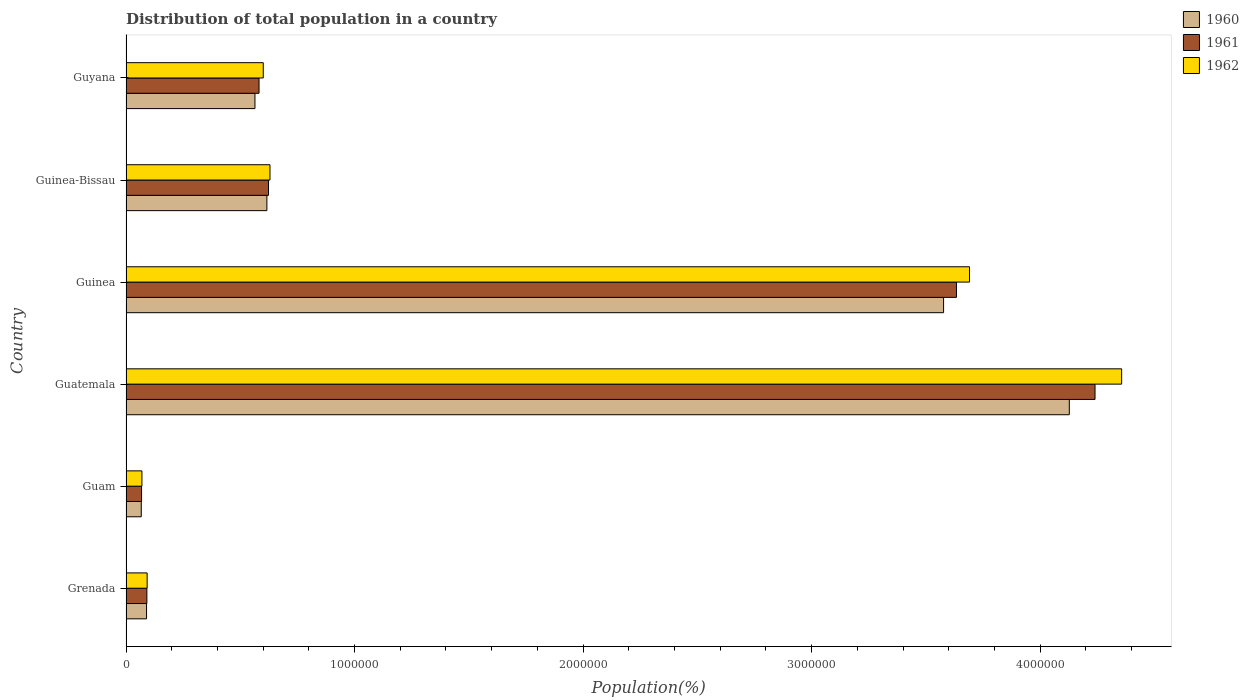How many groups of bars are there?
Offer a terse response. 6. How many bars are there on the 6th tick from the bottom?
Your response must be concise. 3. What is the label of the 5th group of bars from the top?
Provide a short and direct response. Guam. In how many cases, is the number of bars for a given country not equal to the number of legend labels?
Give a very brief answer. 0. What is the population of in 1962 in Guyana?
Keep it short and to the point. 6.01e+05. Across all countries, what is the maximum population of in 1961?
Provide a succinct answer. 4.24e+06. Across all countries, what is the minimum population of in 1962?
Keep it short and to the point. 6.96e+04. In which country was the population of in 1961 maximum?
Your answer should be very brief. Guatemala. In which country was the population of in 1961 minimum?
Your answer should be very brief. Guam. What is the total population of in 1962 in the graph?
Provide a short and direct response. 9.44e+06. What is the difference between the population of in 1961 in Grenada and that in Guinea?
Ensure brevity in your answer.  -3.54e+06. What is the difference between the population of in 1962 in Guyana and the population of in 1960 in Guinea?
Provide a succinct answer. -2.98e+06. What is the average population of in 1961 per country?
Your answer should be very brief. 1.54e+06. What is the difference between the population of in 1960 and population of in 1962 in Guinea?
Your answer should be very brief. -1.14e+05. What is the ratio of the population of in 1962 in Guatemala to that in Guinea?
Offer a terse response. 1.18. Is the difference between the population of in 1960 in Guam and Guinea greater than the difference between the population of in 1962 in Guam and Guinea?
Your answer should be very brief. Yes. What is the difference between the highest and the second highest population of in 1960?
Offer a terse response. 5.50e+05. What is the difference between the highest and the lowest population of in 1961?
Provide a short and direct response. 4.17e+06. In how many countries, is the population of in 1960 greater than the average population of in 1960 taken over all countries?
Offer a very short reply. 2. Are all the bars in the graph horizontal?
Your response must be concise. Yes. What is the difference between two consecutive major ticks on the X-axis?
Your answer should be very brief. 1.00e+06. Are the values on the major ticks of X-axis written in scientific E-notation?
Offer a terse response. No. Does the graph contain any zero values?
Offer a terse response. No. Does the graph contain grids?
Your response must be concise. No. How are the legend labels stacked?
Keep it short and to the point. Vertical. What is the title of the graph?
Your answer should be very brief. Distribution of total population in a country. What is the label or title of the X-axis?
Offer a very short reply. Population(%). What is the Population(%) of 1960 in Grenada?
Your answer should be compact. 8.99e+04. What is the Population(%) of 1961 in Grenada?
Your answer should be very brief. 9.13e+04. What is the Population(%) in 1962 in Grenada?
Your answer should be compact. 9.24e+04. What is the Population(%) in 1960 in Guam?
Your answer should be very brief. 6.67e+04. What is the Population(%) of 1961 in Guam?
Offer a very short reply. 6.81e+04. What is the Population(%) of 1962 in Guam?
Keep it short and to the point. 6.96e+04. What is the Population(%) of 1960 in Guatemala?
Offer a very short reply. 4.13e+06. What is the Population(%) in 1961 in Guatemala?
Give a very brief answer. 4.24e+06. What is the Population(%) of 1962 in Guatemala?
Make the answer very short. 4.36e+06. What is the Population(%) in 1960 in Guinea?
Your answer should be compact. 3.58e+06. What is the Population(%) in 1961 in Guinea?
Provide a short and direct response. 3.63e+06. What is the Population(%) in 1962 in Guinea?
Your response must be concise. 3.69e+06. What is the Population(%) in 1960 in Guinea-Bissau?
Your response must be concise. 6.16e+05. What is the Population(%) in 1961 in Guinea-Bissau?
Your answer should be compact. 6.23e+05. What is the Population(%) of 1962 in Guinea-Bissau?
Your answer should be very brief. 6.30e+05. What is the Population(%) in 1960 in Guyana?
Your answer should be compact. 5.64e+05. What is the Population(%) in 1961 in Guyana?
Offer a very short reply. 5.82e+05. What is the Population(%) of 1962 in Guyana?
Your response must be concise. 6.01e+05. Across all countries, what is the maximum Population(%) of 1960?
Your response must be concise. 4.13e+06. Across all countries, what is the maximum Population(%) in 1961?
Make the answer very short. 4.24e+06. Across all countries, what is the maximum Population(%) of 1962?
Keep it short and to the point. 4.36e+06. Across all countries, what is the minimum Population(%) of 1960?
Offer a terse response. 6.67e+04. Across all countries, what is the minimum Population(%) of 1961?
Keep it short and to the point. 6.81e+04. Across all countries, what is the minimum Population(%) of 1962?
Ensure brevity in your answer.  6.96e+04. What is the total Population(%) of 1960 in the graph?
Your answer should be compact. 9.04e+06. What is the total Population(%) of 1961 in the graph?
Ensure brevity in your answer.  9.24e+06. What is the total Population(%) in 1962 in the graph?
Offer a very short reply. 9.44e+06. What is the difference between the Population(%) in 1960 in Grenada and that in Guam?
Your response must be concise. 2.31e+04. What is the difference between the Population(%) of 1961 in Grenada and that in Guam?
Make the answer very short. 2.32e+04. What is the difference between the Population(%) of 1962 in Grenada and that in Guam?
Offer a very short reply. 2.28e+04. What is the difference between the Population(%) in 1960 in Grenada and that in Guatemala?
Ensure brevity in your answer.  -4.04e+06. What is the difference between the Population(%) of 1961 in Grenada and that in Guatemala?
Your answer should be compact. -4.15e+06. What is the difference between the Population(%) in 1962 in Grenada and that in Guatemala?
Give a very brief answer. -4.26e+06. What is the difference between the Population(%) in 1960 in Grenada and that in Guinea?
Offer a very short reply. -3.49e+06. What is the difference between the Population(%) in 1961 in Grenada and that in Guinea?
Give a very brief answer. -3.54e+06. What is the difference between the Population(%) of 1962 in Grenada and that in Guinea?
Keep it short and to the point. -3.60e+06. What is the difference between the Population(%) of 1960 in Grenada and that in Guinea-Bissau?
Make the answer very short. -5.27e+05. What is the difference between the Population(%) in 1961 in Grenada and that in Guinea-Bissau?
Ensure brevity in your answer.  -5.32e+05. What is the difference between the Population(%) in 1962 in Grenada and that in Guinea-Bissau?
Offer a terse response. -5.38e+05. What is the difference between the Population(%) of 1960 in Grenada and that in Guyana?
Offer a terse response. -4.74e+05. What is the difference between the Population(%) in 1961 in Grenada and that in Guyana?
Your answer should be compact. -4.91e+05. What is the difference between the Population(%) of 1962 in Grenada and that in Guyana?
Give a very brief answer. -5.08e+05. What is the difference between the Population(%) in 1960 in Guam and that in Guatemala?
Provide a short and direct response. -4.06e+06. What is the difference between the Population(%) in 1961 in Guam and that in Guatemala?
Offer a very short reply. -4.17e+06. What is the difference between the Population(%) of 1962 in Guam and that in Guatemala?
Provide a short and direct response. -4.29e+06. What is the difference between the Population(%) in 1960 in Guam and that in Guinea?
Your answer should be very brief. -3.51e+06. What is the difference between the Population(%) of 1961 in Guam and that in Guinea?
Your answer should be very brief. -3.57e+06. What is the difference between the Population(%) of 1962 in Guam and that in Guinea?
Offer a terse response. -3.62e+06. What is the difference between the Population(%) of 1960 in Guam and that in Guinea-Bissau?
Your answer should be compact. -5.50e+05. What is the difference between the Population(%) of 1961 in Guam and that in Guinea-Bissau?
Give a very brief answer. -5.55e+05. What is the difference between the Population(%) of 1962 in Guam and that in Guinea-Bissau?
Offer a very short reply. -5.60e+05. What is the difference between the Population(%) of 1960 in Guam and that in Guyana?
Provide a short and direct response. -4.97e+05. What is the difference between the Population(%) of 1961 in Guam and that in Guyana?
Your response must be concise. -5.14e+05. What is the difference between the Population(%) in 1962 in Guam and that in Guyana?
Make the answer very short. -5.31e+05. What is the difference between the Population(%) in 1960 in Guatemala and that in Guinea?
Provide a succinct answer. 5.50e+05. What is the difference between the Population(%) in 1961 in Guatemala and that in Guinea?
Your answer should be compact. 6.06e+05. What is the difference between the Population(%) of 1962 in Guatemala and that in Guinea?
Make the answer very short. 6.66e+05. What is the difference between the Population(%) of 1960 in Guatemala and that in Guinea-Bissau?
Your answer should be very brief. 3.51e+06. What is the difference between the Population(%) in 1961 in Guatemala and that in Guinea-Bissau?
Give a very brief answer. 3.62e+06. What is the difference between the Population(%) of 1962 in Guatemala and that in Guinea-Bissau?
Your answer should be very brief. 3.73e+06. What is the difference between the Population(%) in 1960 in Guatemala and that in Guyana?
Provide a short and direct response. 3.56e+06. What is the difference between the Population(%) in 1961 in Guatemala and that in Guyana?
Make the answer very short. 3.66e+06. What is the difference between the Population(%) in 1962 in Guatemala and that in Guyana?
Keep it short and to the point. 3.76e+06. What is the difference between the Population(%) in 1960 in Guinea and that in Guinea-Bissau?
Your response must be concise. 2.96e+06. What is the difference between the Population(%) in 1961 in Guinea and that in Guinea-Bissau?
Your answer should be very brief. 3.01e+06. What is the difference between the Population(%) of 1962 in Guinea and that in Guinea-Bissau?
Offer a terse response. 3.06e+06. What is the difference between the Population(%) in 1960 in Guinea and that in Guyana?
Ensure brevity in your answer.  3.01e+06. What is the difference between the Population(%) of 1961 in Guinea and that in Guyana?
Provide a succinct answer. 3.05e+06. What is the difference between the Population(%) of 1962 in Guinea and that in Guyana?
Provide a short and direct response. 3.09e+06. What is the difference between the Population(%) in 1960 in Guinea-Bissau and that in Guyana?
Ensure brevity in your answer.  5.22e+04. What is the difference between the Population(%) in 1961 in Guinea-Bissau and that in Guyana?
Your answer should be compact. 4.14e+04. What is the difference between the Population(%) of 1962 in Guinea-Bissau and that in Guyana?
Give a very brief answer. 2.94e+04. What is the difference between the Population(%) of 1960 in Grenada and the Population(%) of 1961 in Guam?
Keep it short and to the point. 2.18e+04. What is the difference between the Population(%) of 1960 in Grenada and the Population(%) of 1962 in Guam?
Ensure brevity in your answer.  2.03e+04. What is the difference between the Population(%) of 1961 in Grenada and the Population(%) of 1962 in Guam?
Offer a very short reply. 2.17e+04. What is the difference between the Population(%) in 1960 in Grenada and the Population(%) in 1961 in Guatemala?
Ensure brevity in your answer.  -4.15e+06. What is the difference between the Population(%) of 1960 in Grenada and the Population(%) of 1962 in Guatemala?
Make the answer very short. -4.27e+06. What is the difference between the Population(%) of 1961 in Grenada and the Population(%) of 1962 in Guatemala?
Your answer should be compact. -4.27e+06. What is the difference between the Population(%) in 1960 in Grenada and the Population(%) in 1961 in Guinea?
Make the answer very short. -3.54e+06. What is the difference between the Population(%) in 1960 in Grenada and the Population(%) in 1962 in Guinea?
Make the answer very short. -3.60e+06. What is the difference between the Population(%) in 1961 in Grenada and the Population(%) in 1962 in Guinea?
Your answer should be very brief. -3.60e+06. What is the difference between the Population(%) of 1960 in Grenada and the Population(%) of 1961 in Guinea-Bissau?
Your answer should be compact. -5.34e+05. What is the difference between the Population(%) in 1960 in Grenada and the Population(%) in 1962 in Guinea-Bissau?
Provide a succinct answer. -5.40e+05. What is the difference between the Population(%) in 1961 in Grenada and the Population(%) in 1962 in Guinea-Bissau?
Ensure brevity in your answer.  -5.39e+05. What is the difference between the Population(%) of 1960 in Grenada and the Population(%) of 1961 in Guyana?
Offer a very short reply. -4.92e+05. What is the difference between the Population(%) of 1960 in Grenada and the Population(%) of 1962 in Guyana?
Your answer should be very brief. -5.11e+05. What is the difference between the Population(%) in 1961 in Grenada and the Population(%) in 1962 in Guyana?
Keep it short and to the point. -5.09e+05. What is the difference between the Population(%) of 1960 in Guam and the Population(%) of 1961 in Guatemala?
Make the answer very short. -4.17e+06. What is the difference between the Population(%) in 1960 in Guam and the Population(%) in 1962 in Guatemala?
Your answer should be compact. -4.29e+06. What is the difference between the Population(%) of 1961 in Guam and the Population(%) of 1962 in Guatemala?
Your answer should be very brief. -4.29e+06. What is the difference between the Population(%) of 1960 in Guam and the Population(%) of 1961 in Guinea?
Ensure brevity in your answer.  -3.57e+06. What is the difference between the Population(%) in 1960 in Guam and the Population(%) in 1962 in Guinea?
Make the answer very short. -3.62e+06. What is the difference between the Population(%) of 1961 in Guam and the Population(%) of 1962 in Guinea?
Your response must be concise. -3.62e+06. What is the difference between the Population(%) of 1960 in Guam and the Population(%) of 1961 in Guinea-Bissau?
Your answer should be compact. -5.57e+05. What is the difference between the Population(%) in 1960 in Guam and the Population(%) in 1962 in Guinea-Bissau?
Give a very brief answer. -5.63e+05. What is the difference between the Population(%) of 1961 in Guam and the Population(%) of 1962 in Guinea-Bissau?
Make the answer very short. -5.62e+05. What is the difference between the Population(%) in 1960 in Guam and the Population(%) in 1961 in Guyana?
Your response must be concise. -5.15e+05. What is the difference between the Population(%) in 1960 in Guam and the Population(%) in 1962 in Guyana?
Provide a short and direct response. -5.34e+05. What is the difference between the Population(%) in 1961 in Guam and the Population(%) in 1962 in Guyana?
Your answer should be very brief. -5.32e+05. What is the difference between the Population(%) in 1960 in Guatemala and the Population(%) in 1961 in Guinea?
Give a very brief answer. 4.94e+05. What is the difference between the Population(%) in 1960 in Guatemala and the Population(%) in 1962 in Guinea?
Your response must be concise. 4.37e+05. What is the difference between the Population(%) of 1961 in Guatemala and the Population(%) of 1962 in Guinea?
Your answer should be compact. 5.49e+05. What is the difference between the Population(%) of 1960 in Guatemala and the Population(%) of 1961 in Guinea-Bissau?
Offer a very short reply. 3.50e+06. What is the difference between the Population(%) of 1960 in Guatemala and the Population(%) of 1962 in Guinea-Bissau?
Give a very brief answer. 3.50e+06. What is the difference between the Population(%) of 1961 in Guatemala and the Population(%) of 1962 in Guinea-Bissau?
Your response must be concise. 3.61e+06. What is the difference between the Population(%) in 1960 in Guatemala and the Population(%) in 1961 in Guyana?
Your response must be concise. 3.55e+06. What is the difference between the Population(%) of 1960 in Guatemala and the Population(%) of 1962 in Guyana?
Provide a short and direct response. 3.53e+06. What is the difference between the Population(%) of 1961 in Guatemala and the Population(%) of 1962 in Guyana?
Offer a very short reply. 3.64e+06. What is the difference between the Population(%) of 1960 in Guinea and the Population(%) of 1961 in Guinea-Bissau?
Your answer should be compact. 2.95e+06. What is the difference between the Population(%) in 1960 in Guinea and the Population(%) in 1962 in Guinea-Bissau?
Make the answer very short. 2.95e+06. What is the difference between the Population(%) of 1961 in Guinea and the Population(%) of 1962 in Guinea-Bissau?
Your response must be concise. 3.00e+06. What is the difference between the Population(%) in 1960 in Guinea and the Population(%) in 1961 in Guyana?
Offer a very short reply. 3.00e+06. What is the difference between the Population(%) in 1960 in Guinea and the Population(%) in 1962 in Guyana?
Provide a succinct answer. 2.98e+06. What is the difference between the Population(%) in 1961 in Guinea and the Population(%) in 1962 in Guyana?
Give a very brief answer. 3.03e+06. What is the difference between the Population(%) in 1960 in Guinea-Bissau and the Population(%) in 1961 in Guyana?
Offer a very short reply. 3.44e+04. What is the difference between the Population(%) in 1960 in Guinea-Bissau and the Population(%) in 1962 in Guyana?
Make the answer very short. 1.58e+04. What is the difference between the Population(%) of 1961 in Guinea-Bissau and the Population(%) of 1962 in Guyana?
Your response must be concise. 2.29e+04. What is the average Population(%) of 1960 per country?
Provide a short and direct response. 1.51e+06. What is the average Population(%) in 1961 per country?
Your response must be concise. 1.54e+06. What is the average Population(%) in 1962 per country?
Your response must be concise. 1.57e+06. What is the difference between the Population(%) in 1960 and Population(%) in 1961 in Grenada?
Your answer should be very brief. -1399. What is the difference between the Population(%) of 1960 and Population(%) of 1962 in Grenada?
Give a very brief answer. -2563. What is the difference between the Population(%) in 1961 and Population(%) in 1962 in Grenada?
Your answer should be very brief. -1164. What is the difference between the Population(%) in 1960 and Population(%) in 1961 in Guam?
Your answer should be compact. -1332. What is the difference between the Population(%) of 1960 and Population(%) of 1962 in Guam?
Give a very brief answer. -2866. What is the difference between the Population(%) in 1961 and Population(%) in 1962 in Guam?
Your answer should be compact. -1534. What is the difference between the Population(%) of 1960 and Population(%) of 1961 in Guatemala?
Keep it short and to the point. -1.13e+05. What is the difference between the Population(%) of 1960 and Population(%) of 1962 in Guatemala?
Give a very brief answer. -2.29e+05. What is the difference between the Population(%) of 1961 and Population(%) of 1962 in Guatemala?
Offer a terse response. -1.16e+05. What is the difference between the Population(%) of 1960 and Population(%) of 1961 in Guinea?
Provide a succinct answer. -5.64e+04. What is the difference between the Population(%) in 1960 and Population(%) in 1962 in Guinea?
Your response must be concise. -1.14e+05. What is the difference between the Population(%) in 1961 and Population(%) in 1962 in Guinea?
Give a very brief answer. -5.72e+04. What is the difference between the Population(%) in 1960 and Population(%) in 1961 in Guinea-Bissau?
Provide a succinct answer. -7006. What is the difference between the Population(%) of 1960 and Population(%) of 1962 in Guinea-Bissau?
Your response must be concise. -1.36e+04. What is the difference between the Population(%) in 1961 and Population(%) in 1962 in Guinea-Bissau?
Your response must be concise. -6560. What is the difference between the Population(%) of 1960 and Population(%) of 1961 in Guyana?
Offer a very short reply. -1.78e+04. What is the difference between the Population(%) in 1960 and Population(%) in 1962 in Guyana?
Ensure brevity in your answer.  -3.63e+04. What is the difference between the Population(%) of 1961 and Population(%) of 1962 in Guyana?
Offer a terse response. -1.85e+04. What is the ratio of the Population(%) of 1960 in Grenada to that in Guam?
Keep it short and to the point. 1.35. What is the ratio of the Population(%) of 1961 in Grenada to that in Guam?
Offer a terse response. 1.34. What is the ratio of the Population(%) of 1962 in Grenada to that in Guam?
Offer a terse response. 1.33. What is the ratio of the Population(%) of 1960 in Grenada to that in Guatemala?
Your answer should be compact. 0.02. What is the ratio of the Population(%) in 1961 in Grenada to that in Guatemala?
Your response must be concise. 0.02. What is the ratio of the Population(%) in 1962 in Grenada to that in Guatemala?
Offer a terse response. 0.02. What is the ratio of the Population(%) in 1960 in Grenada to that in Guinea?
Ensure brevity in your answer.  0.03. What is the ratio of the Population(%) of 1961 in Grenada to that in Guinea?
Provide a succinct answer. 0.03. What is the ratio of the Population(%) of 1962 in Grenada to that in Guinea?
Give a very brief answer. 0.03. What is the ratio of the Population(%) in 1960 in Grenada to that in Guinea-Bissau?
Give a very brief answer. 0.15. What is the ratio of the Population(%) in 1961 in Grenada to that in Guinea-Bissau?
Offer a very short reply. 0.15. What is the ratio of the Population(%) in 1962 in Grenada to that in Guinea-Bissau?
Make the answer very short. 0.15. What is the ratio of the Population(%) in 1960 in Grenada to that in Guyana?
Give a very brief answer. 0.16. What is the ratio of the Population(%) in 1961 in Grenada to that in Guyana?
Make the answer very short. 0.16. What is the ratio of the Population(%) in 1962 in Grenada to that in Guyana?
Your response must be concise. 0.15. What is the ratio of the Population(%) of 1960 in Guam to that in Guatemala?
Your answer should be compact. 0.02. What is the ratio of the Population(%) of 1961 in Guam to that in Guatemala?
Your answer should be compact. 0.02. What is the ratio of the Population(%) in 1962 in Guam to that in Guatemala?
Keep it short and to the point. 0.02. What is the ratio of the Population(%) of 1960 in Guam to that in Guinea?
Your answer should be compact. 0.02. What is the ratio of the Population(%) in 1961 in Guam to that in Guinea?
Your response must be concise. 0.02. What is the ratio of the Population(%) in 1962 in Guam to that in Guinea?
Your answer should be compact. 0.02. What is the ratio of the Population(%) in 1960 in Guam to that in Guinea-Bissau?
Ensure brevity in your answer.  0.11. What is the ratio of the Population(%) of 1961 in Guam to that in Guinea-Bissau?
Give a very brief answer. 0.11. What is the ratio of the Population(%) in 1962 in Guam to that in Guinea-Bissau?
Offer a very short reply. 0.11. What is the ratio of the Population(%) in 1960 in Guam to that in Guyana?
Your answer should be compact. 0.12. What is the ratio of the Population(%) in 1961 in Guam to that in Guyana?
Keep it short and to the point. 0.12. What is the ratio of the Population(%) in 1962 in Guam to that in Guyana?
Offer a terse response. 0.12. What is the ratio of the Population(%) of 1960 in Guatemala to that in Guinea?
Your answer should be very brief. 1.15. What is the ratio of the Population(%) of 1961 in Guatemala to that in Guinea?
Offer a terse response. 1.17. What is the ratio of the Population(%) in 1962 in Guatemala to that in Guinea?
Offer a very short reply. 1.18. What is the ratio of the Population(%) of 1960 in Guatemala to that in Guinea-Bissau?
Your answer should be compact. 6.7. What is the ratio of the Population(%) in 1961 in Guatemala to that in Guinea-Bissau?
Offer a terse response. 6.8. What is the ratio of the Population(%) in 1962 in Guatemala to that in Guinea-Bissau?
Offer a terse response. 6.92. What is the ratio of the Population(%) in 1960 in Guatemala to that in Guyana?
Your answer should be compact. 7.32. What is the ratio of the Population(%) of 1961 in Guatemala to that in Guyana?
Ensure brevity in your answer.  7.28. What is the ratio of the Population(%) in 1962 in Guatemala to that in Guyana?
Make the answer very short. 7.25. What is the ratio of the Population(%) in 1960 in Guinea to that in Guinea-Bissau?
Your response must be concise. 5.8. What is the ratio of the Population(%) in 1961 in Guinea to that in Guinea-Bissau?
Your answer should be very brief. 5.83. What is the ratio of the Population(%) in 1962 in Guinea to that in Guinea-Bissau?
Give a very brief answer. 5.86. What is the ratio of the Population(%) in 1960 in Guinea to that in Guyana?
Keep it short and to the point. 6.34. What is the ratio of the Population(%) of 1961 in Guinea to that in Guyana?
Make the answer very short. 6.24. What is the ratio of the Population(%) of 1962 in Guinea to that in Guyana?
Keep it short and to the point. 6.15. What is the ratio of the Population(%) of 1960 in Guinea-Bissau to that in Guyana?
Your answer should be compact. 1.09. What is the ratio of the Population(%) in 1961 in Guinea-Bissau to that in Guyana?
Your answer should be very brief. 1.07. What is the ratio of the Population(%) in 1962 in Guinea-Bissau to that in Guyana?
Provide a short and direct response. 1.05. What is the difference between the highest and the second highest Population(%) in 1960?
Your answer should be very brief. 5.50e+05. What is the difference between the highest and the second highest Population(%) of 1961?
Provide a short and direct response. 6.06e+05. What is the difference between the highest and the second highest Population(%) of 1962?
Offer a very short reply. 6.66e+05. What is the difference between the highest and the lowest Population(%) in 1960?
Your answer should be compact. 4.06e+06. What is the difference between the highest and the lowest Population(%) in 1961?
Offer a terse response. 4.17e+06. What is the difference between the highest and the lowest Population(%) in 1962?
Offer a terse response. 4.29e+06. 